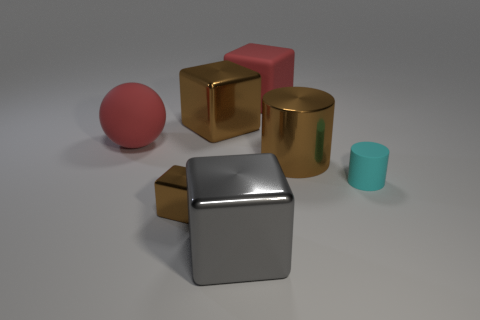What shape is the thing that is the same color as the matte block?
Make the answer very short. Sphere. There is a brown thing that is behind the big red matte object that is left of the gray cube; what is its size?
Make the answer very short. Large. There is a big object that is in front of the small matte object; is it the same shape as the tiny thing that is in front of the cyan cylinder?
Provide a short and direct response. Yes. Is the number of large red matte cubes to the right of the large red block the same as the number of tiny blue shiny objects?
Offer a very short reply. Yes. What is the color of the other big shiny thing that is the same shape as the gray object?
Make the answer very short. Brown. Are the red thing that is behind the red matte sphere and the tiny cyan thing made of the same material?
Ensure brevity in your answer.  Yes. What number of tiny things are either brown blocks or cylinders?
Your answer should be compact. 2. How big is the cyan object?
Your answer should be compact. Small. Is the size of the cyan cylinder the same as the brown cube behind the large metallic cylinder?
Keep it short and to the point. No. What number of cyan things are either blocks or tiny objects?
Make the answer very short. 1. 